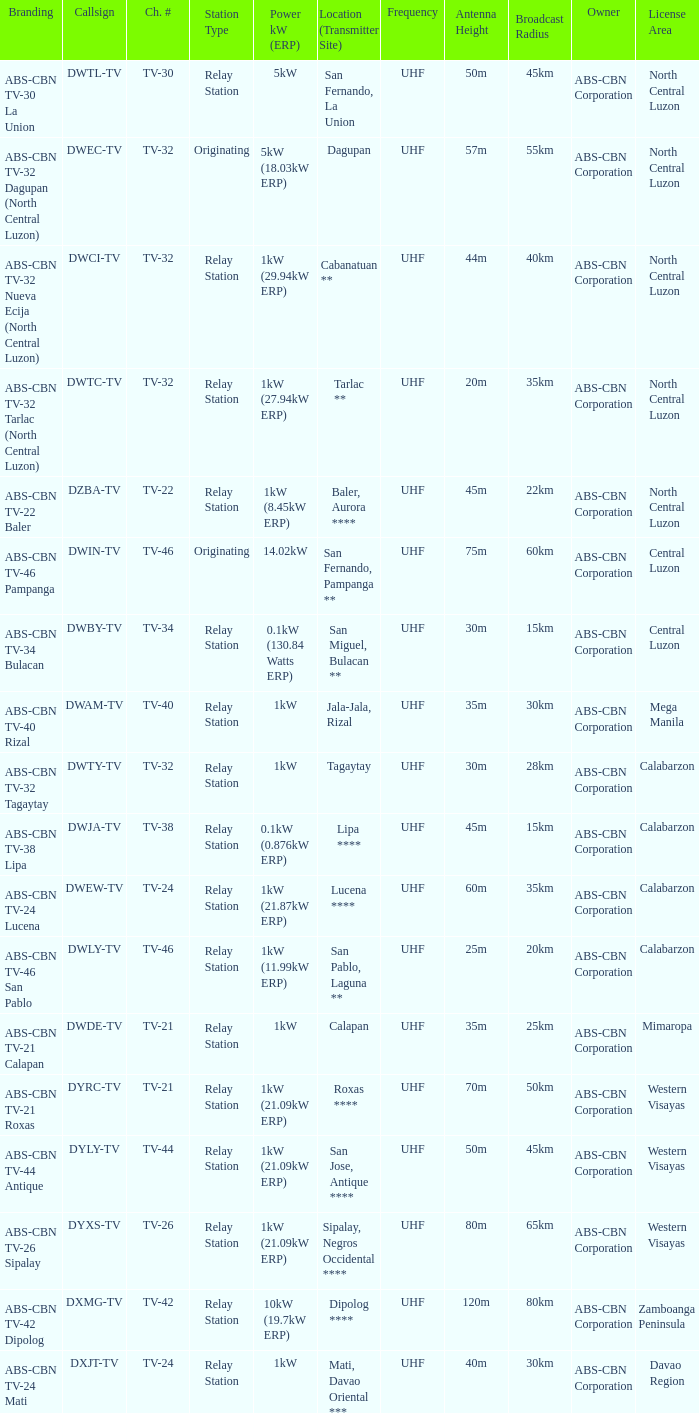Help me parse the entirety of this table. {'header': ['Branding', 'Callsign', 'Ch. #', 'Station Type', 'Power kW (ERP)', 'Location (Transmitter Site)', 'Frequency', 'Antenna Height', 'Broadcast Radius', 'Owner', 'License Area'], 'rows': [['ABS-CBN TV-30 La Union', 'DWTL-TV', 'TV-30', 'Relay Station', '5kW', 'San Fernando, La Union', 'UHF', '50m', '45km', 'ABS-CBN Corporation', 'North Central Luzon'], ['ABS-CBN TV-32 Dagupan (North Central Luzon)', 'DWEC-TV', 'TV-32', 'Originating', '5kW (18.03kW ERP)', 'Dagupan', 'UHF', '57m', '55km', 'ABS-CBN Corporation', 'North Central Luzon'], ['ABS-CBN TV-32 Nueva Ecija (North Central Luzon)', 'DWCI-TV', 'TV-32', 'Relay Station', '1kW (29.94kW ERP)', 'Cabanatuan **', 'UHF', '44m', '40km', 'ABS-CBN Corporation', 'North Central Luzon'], ['ABS-CBN TV-32 Tarlac (North Central Luzon)', 'DWTC-TV', 'TV-32', 'Relay Station', '1kW (27.94kW ERP)', 'Tarlac **', 'UHF', '20m', '35km', 'ABS-CBN Corporation', 'North Central Luzon'], ['ABS-CBN TV-22 Baler', 'DZBA-TV', 'TV-22', 'Relay Station', '1kW (8.45kW ERP)', 'Baler, Aurora ****', 'UHF', '45m', '22km', 'ABS-CBN Corporation', 'North Central Luzon'], ['ABS-CBN TV-46 Pampanga', 'DWIN-TV', 'TV-46', 'Originating', '14.02kW', 'San Fernando, Pampanga **', 'UHF', '75m', '60km', 'ABS-CBN Corporation', 'Central Luzon'], ['ABS-CBN TV-34 Bulacan', 'DWBY-TV', 'TV-34', 'Relay Station', '0.1kW (130.84 Watts ERP)', 'San Miguel, Bulacan **', 'UHF', '30m', '15km', 'ABS-CBN Corporation', 'Central Luzon'], ['ABS-CBN TV-40 Rizal', 'DWAM-TV', 'TV-40', 'Relay Station', '1kW', 'Jala-Jala, Rizal', 'UHF', '35m', '30km', 'ABS-CBN Corporation', 'Mega Manila'], ['ABS-CBN TV-32 Tagaytay', 'DWTY-TV', 'TV-32', 'Relay Station', '1kW', 'Tagaytay', 'UHF', '30m', '28km', 'ABS-CBN Corporation', 'Calabarzon'], ['ABS-CBN TV-38 Lipa', 'DWJA-TV', 'TV-38', 'Relay Station', '0.1kW (0.876kW ERP)', 'Lipa ****', 'UHF', '45m', '15km', 'ABS-CBN Corporation', 'Calabarzon'], ['ABS-CBN TV-24 Lucena', 'DWEW-TV', 'TV-24', 'Relay Station', '1kW (21.87kW ERP)', 'Lucena ****', 'UHF', '60m', '35km', 'ABS-CBN Corporation', 'Calabarzon'], ['ABS-CBN TV-46 San Pablo', 'DWLY-TV', 'TV-46', 'Relay Station', '1kW (11.99kW ERP)', 'San Pablo, Laguna **', 'UHF', '25m', '20km', 'ABS-CBN Corporation', 'Calabarzon'], ['ABS-CBN TV-21 Calapan', 'DWDE-TV', 'TV-21', 'Relay Station', '1kW', 'Calapan', 'UHF', '35m', '25km', 'ABS-CBN Corporation', 'Mimaropa'], ['ABS-CBN TV-21 Roxas', 'DYRC-TV', 'TV-21', 'Relay Station', '1kW (21.09kW ERP)', 'Roxas ****', 'UHF', '70m', '50km', 'ABS-CBN Corporation', 'Western Visayas'], ['ABS-CBN TV-44 Antique', 'DYLY-TV', 'TV-44', 'Relay Station', '1kW (21.09kW ERP)', 'San Jose, Antique ****', 'UHF', '50m', '45km', 'ABS-CBN Corporation', 'Western Visayas'], ['ABS-CBN TV-26 Sipalay', 'DYXS-TV', 'TV-26', 'Relay Station', '1kW (21.09kW ERP)', 'Sipalay, Negros Occidental ****', 'UHF', '80m', '65km', 'ABS-CBN Corporation', 'Western Visayas'], ['ABS-CBN TV-42 Dipolog', 'DXMG-TV', 'TV-42', 'Relay Station', '10kW (19.7kW ERP)', 'Dipolog ****', 'UHF', '120m', '80km', 'ABS-CBN Corporation', 'Zamboanga Peninsula'], ['ABS-CBN TV-24 Mati', 'DXJT-TV', 'TV-24', 'Relay Station', '1kW', 'Mati, Davao Oriental ***', 'UHF', '40m', '30km', 'ABS-CBN Corporation', 'Davao Region']]} What is the station type for the branding ABS-CBN TV-32 Tagaytay? Relay Station. 